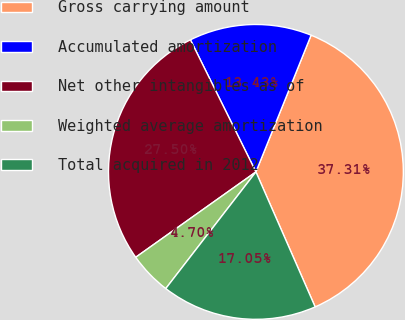<chart> <loc_0><loc_0><loc_500><loc_500><pie_chart><fcel>Gross carrying amount<fcel>Accumulated amortization<fcel>Net other intangibles as of<fcel>Weighted average amortization<fcel>Total acquired in 2012<nl><fcel>37.31%<fcel>13.43%<fcel>27.5%<fcel>4.7%<fcel>17.05%<nl></chart> 